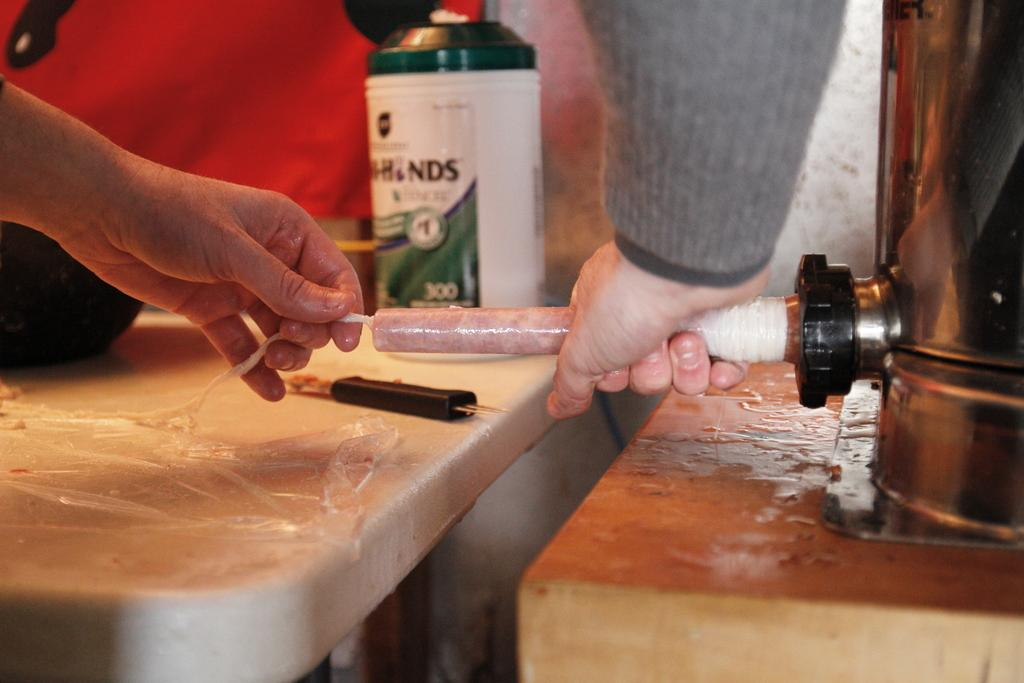<image>
Create a compact narrative representing the image presented. a person making sausage in front of a container with letters  NDS on it 